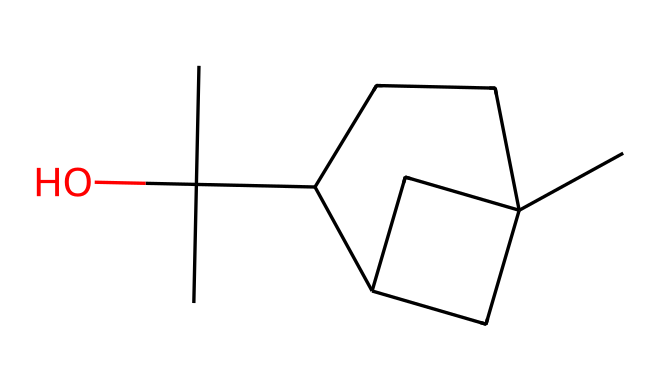What is the molecular formula of camphor? By analyzing the structure represented by the SMILES notation, we can identify the number of carbon (C), hydrogen (H), and oxygen (O) atoms. There are 10 carbon atoms, 16 hydrogen atoms, and 1 oxygen atom, which gives us the formula C10H16O.
Answer: C10H16O How many rings are present in camphor? The structure indicates a cyclic arrangement of carbon atoms, specifically two fused rings in the structure. Therefore, there are two rings in camphor.
Answer: 2 What type of functional group is present in camphor? Upon examining the structure, the presence of a carbonyl group (C=O) within the cyclic ketone's structure indicates that the functional group is a ketone.
Answer: ketone What is the total number of carbon atoms in camphor? By counting the carbon atoms in the SMILES representation, we find there are 10 carbon atoms in the molecular structure of camphor.
Answer: 10 What is the degree of unsaturation in camphor? The degree of unsaturation can be calculated using the formula (2C + 2 + N - H - X)/2, where C is the number of carbons, H is hydrogens, N is nitrogens, and X is halogens. For camphor (C10H16O), this gives a degree of unsaturation of 2, indicating the presence of double bonds or rings.
Answer: 2 What is the predominant type of hybridization for the carbon atoms in camphor? Examining the structure reveals that most carbon atoms in camphor are attached to single bonds and one double bond, which indicates sp3 hybridization for the majority and sp2 for the carbon involved in the carbonyl.
Answer: sp3 and sp2 